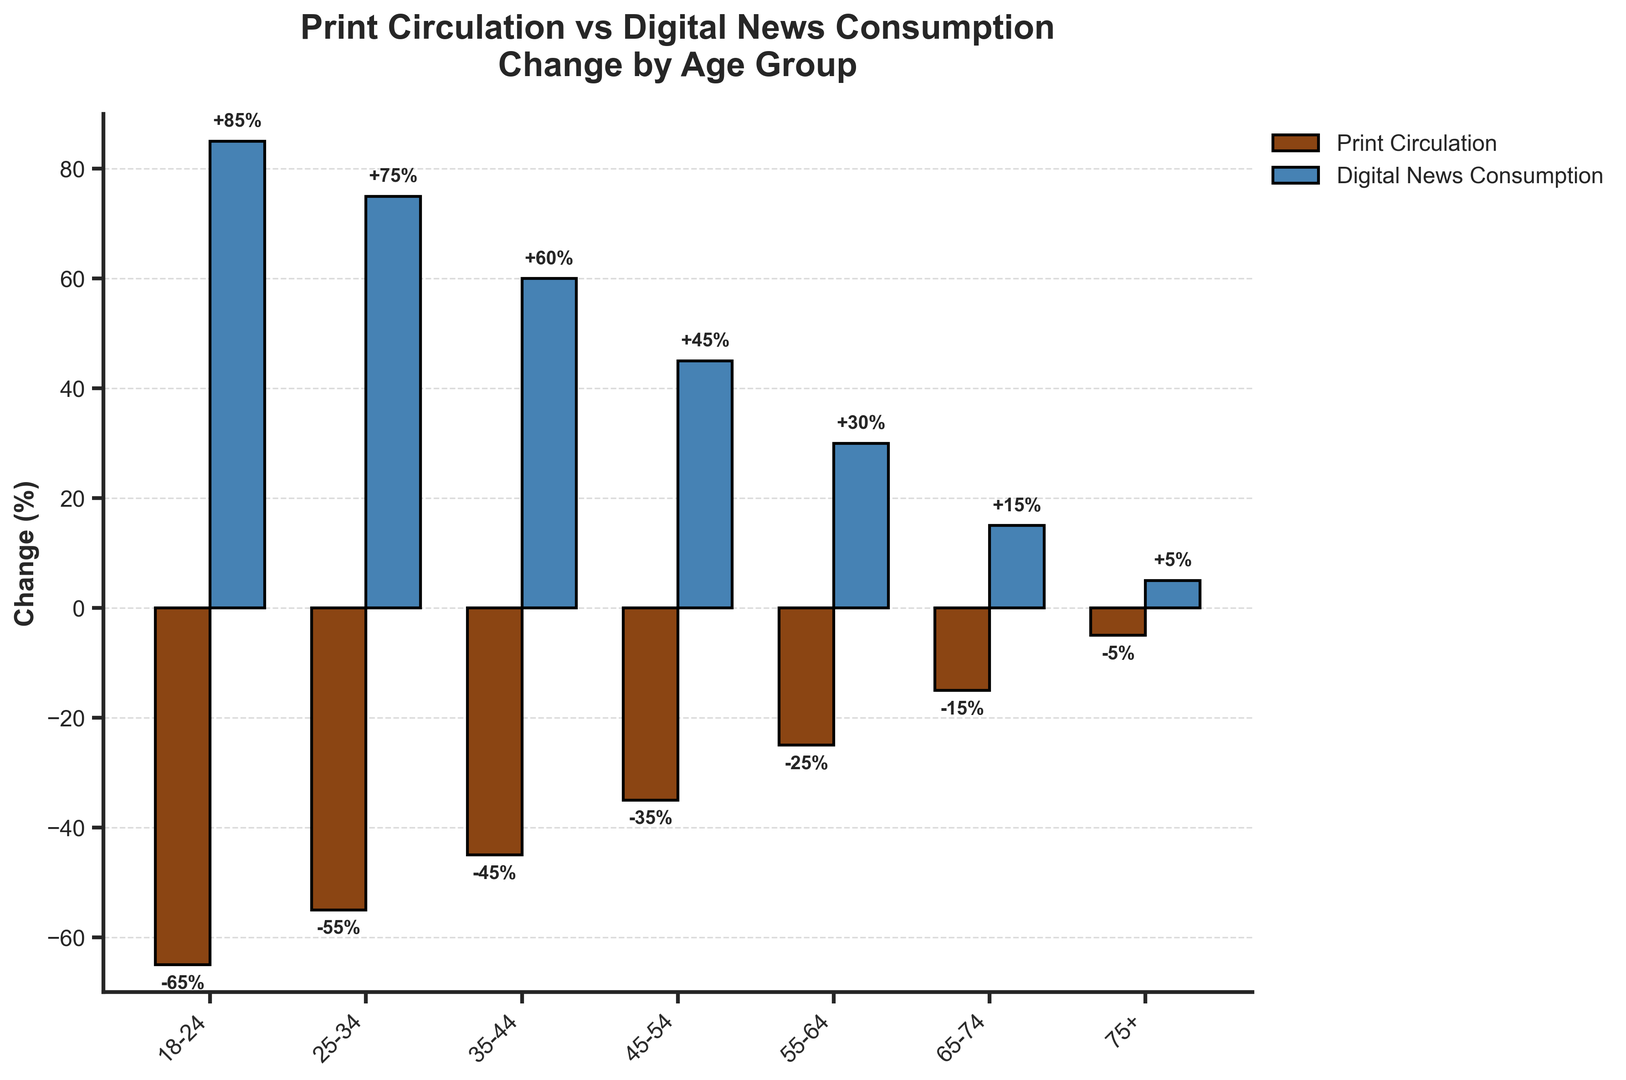What's the average change in print circulation for age groups above 34? To find the average change, sum the percentage changes for the age groups 35-44, 45-54, 55-64, 65-74, and 75+. The values are -45, -35, -25, -15, and -5. Then divide by the number of age groups (5). The calculation is (-45 + -35 + -25 + -15 + -5) / 5 = -125 / 5 = -25
Answer: -25% Which age group experienced the greatest increase in digital news consumption? The greatest increase in digital news consumption is represented by the tallest blue bar. The 18-24 age group has the highest increase at 85%.
Answer: 18-24 Which age group has the smallest decline in print circulation? The smallest decline in print circulation is represented by the shortest brown bar that is below zero. The 75+ age group has the smallest decline at -5%.
Answer: 75+ How does the change in print circulation for the 55-64 age group compare to the change in digital news consumption for the same group? Compare the two bars for the 55-64 age group. The print circulation change is -25% and the digital news consumption change is +30%.
Answer: Print: -25%, Digital: +30% What is the difference in print circulation change between the 18-24 and 65-74 age groups? The print circulation change for the 18-24 age group is -65% and for the 65-74 age group is -15%. Subtract the two values: -65 - (-15) = -65 + 15 = -50.
Answer: -50% Between which two consecutive age groups is the change in digital news consumption the most similar? Look for the smallest difference between the blue bars of consecutive age groups. The change between the 55-64 group (+30%) and 65-74 group (+15%) has a difference of 15%. All other consecutive differences are larger.
Answer: 55-64 and 65-74 Which age group has a larger change in digital news consumption: 25-34 or 35-44? Compare the blue bars for the 25-34 and 35-44 age groups. The change for 25-34 is +75% and for 35-44 is +60%. The 25-34 age group has a larger change.
Answer: 25-34 By how much does the digital news consumption change for the 45-54 age group exceed the print circulation change for the same group? The digital news consumption change for the 45-54 group is +45%. The print circulation change is -35%. The difference is 45% - (-35%) = 45% + 35% = 80%.
Answer: 80% Which age group's digital news consumption change nearly equals the print circulation change of the 25-34 age group? The 25-34 age group has a print circulation change of -55%. The age group with a nearly equal change in digital news consumption is the 18-24 age group with +85%.
Answer: 18-24 